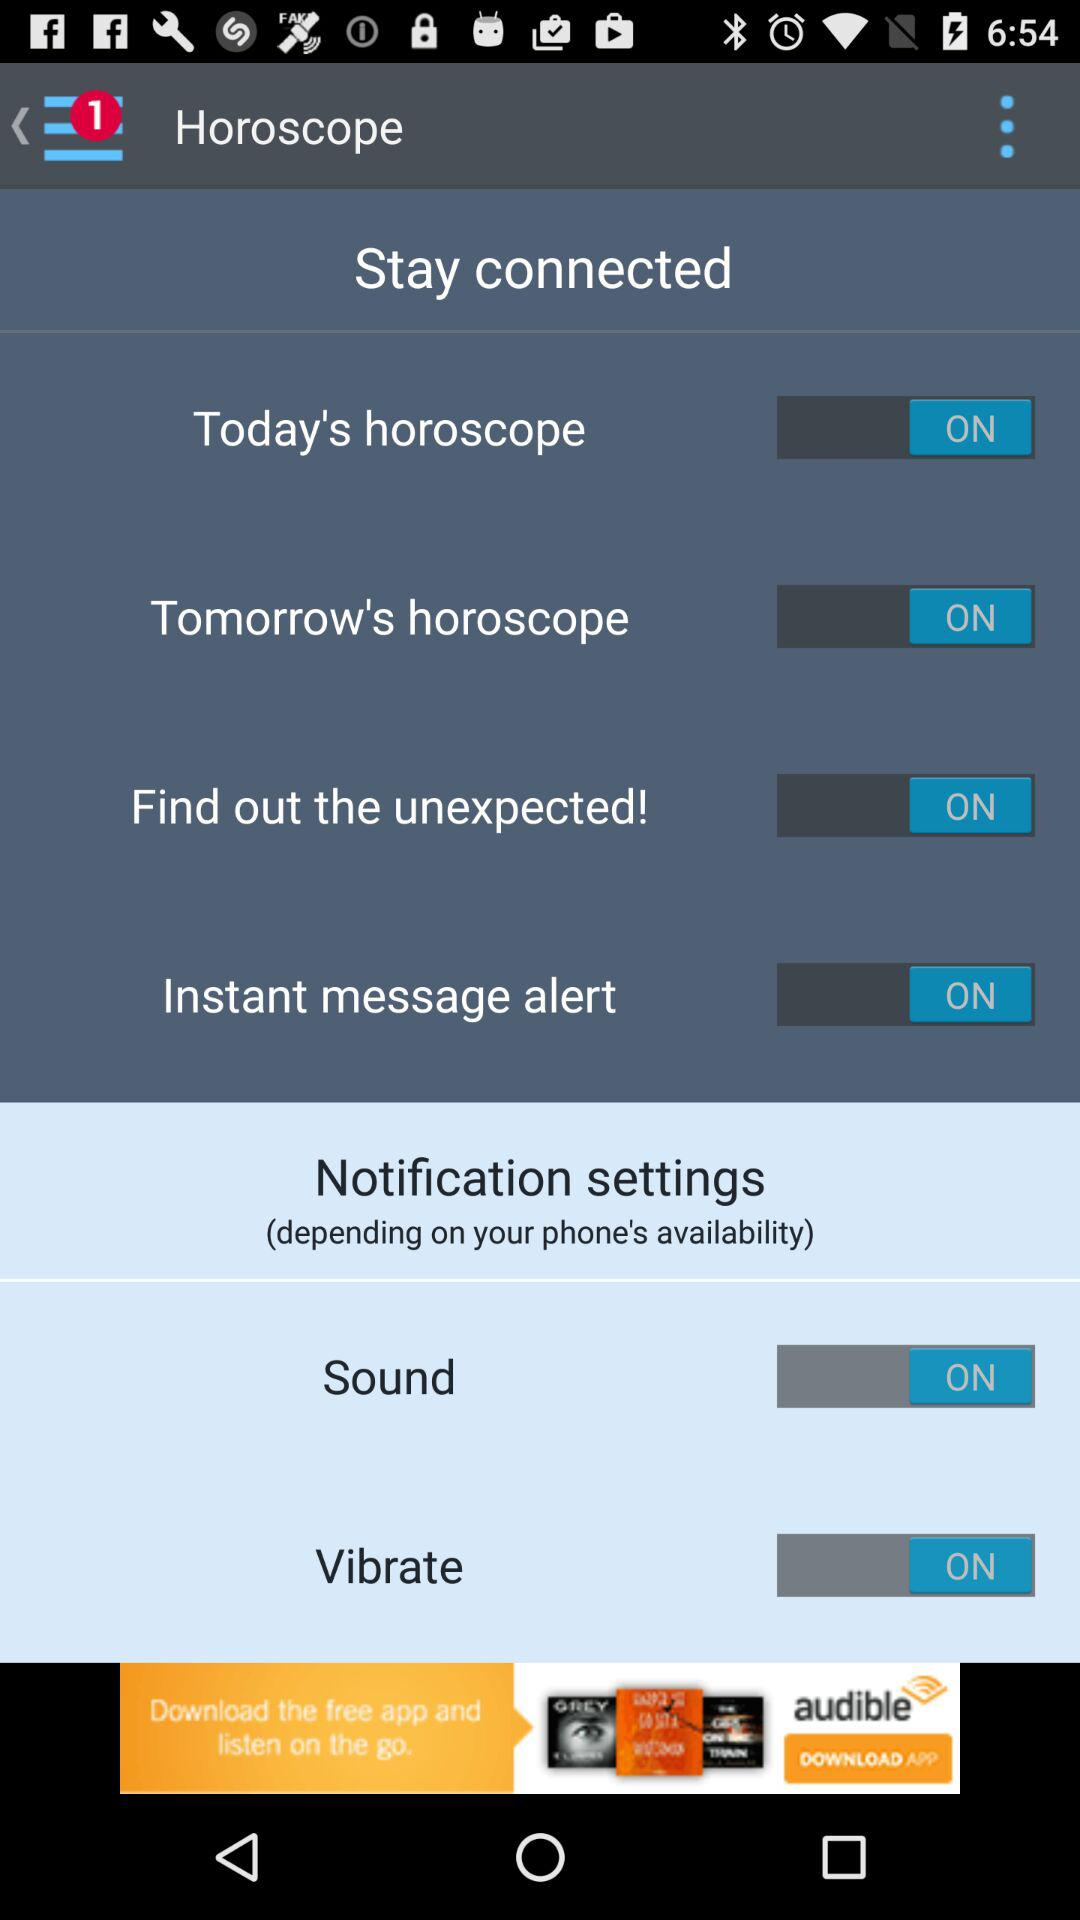On what does "Notification settings" depend? "Notification settings" depend on the "phone's availability". 